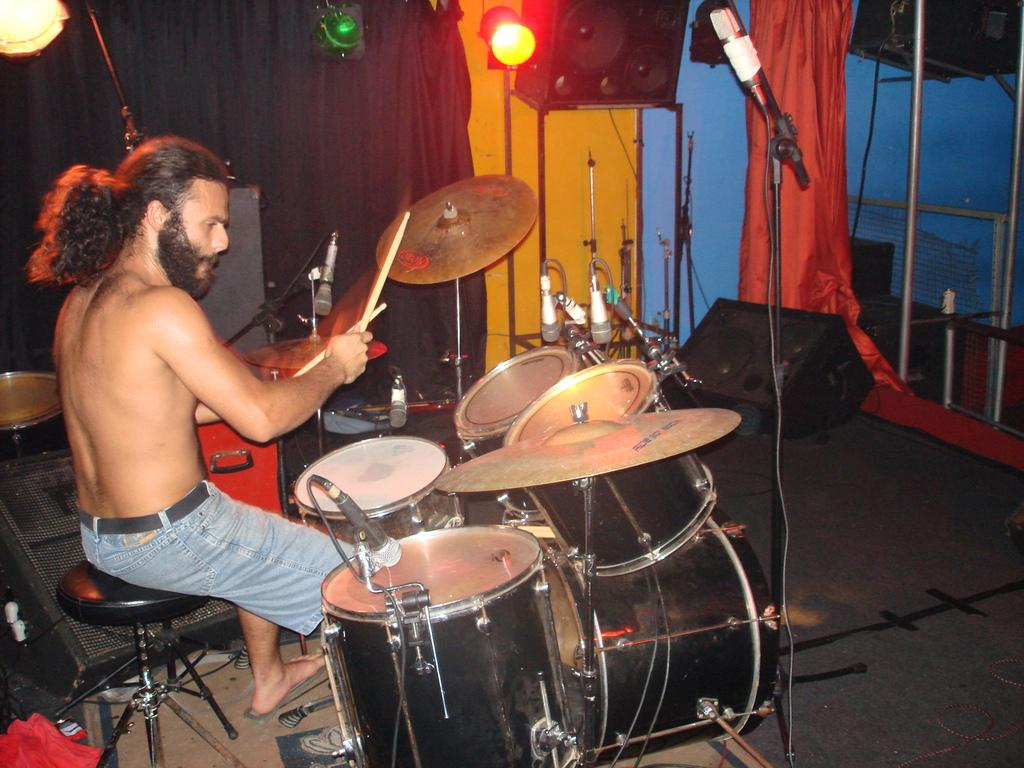Who is the person in the image? There is a man in the image. What is the man doing in the image? The man is playing drums. What objects are around the drums in the image? There are microphones around the drums in the image. What type of hose can be seen connected to the drums in the image? There is no hose connected to the drums in the image. What is the man standing on in the image? The provided facts do not mention a stage or any other surface the man is standing on, so we cannot determine that from the image. 